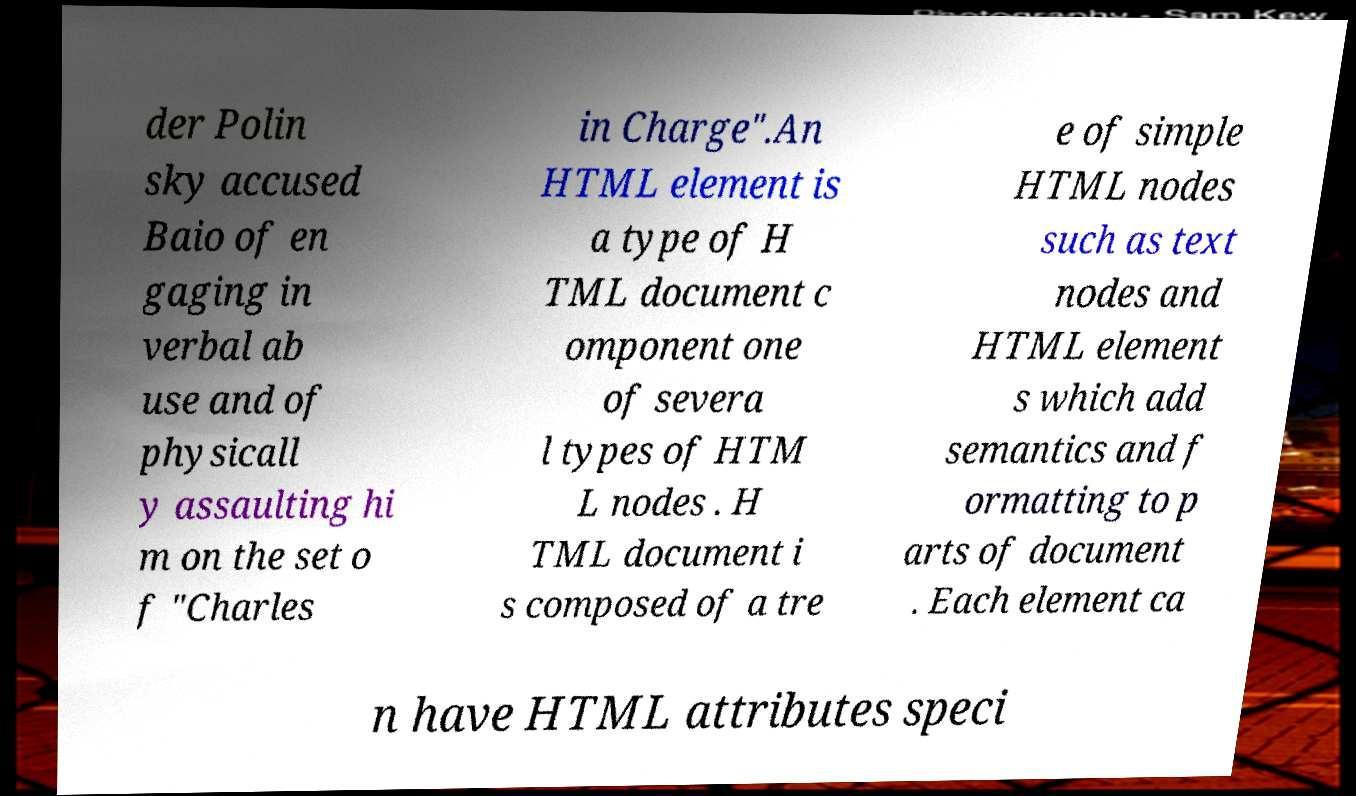Could you assist in decoding the text presented in this image and type it out clearly? der Polin sky accused Baio of en gaging in verbal ab use and of physicall y assaulting hi m on the set o f "Charles in Charge".An HTML element is a type of H TML document c omponent one of severa l types of HTM L nodes . H TML document i s composed of a tre e of simple HTML nodes such as text nodes and HTML element s which add semantics and f ormatting to p arts of document . Each element ca n have HTML attributes speci 